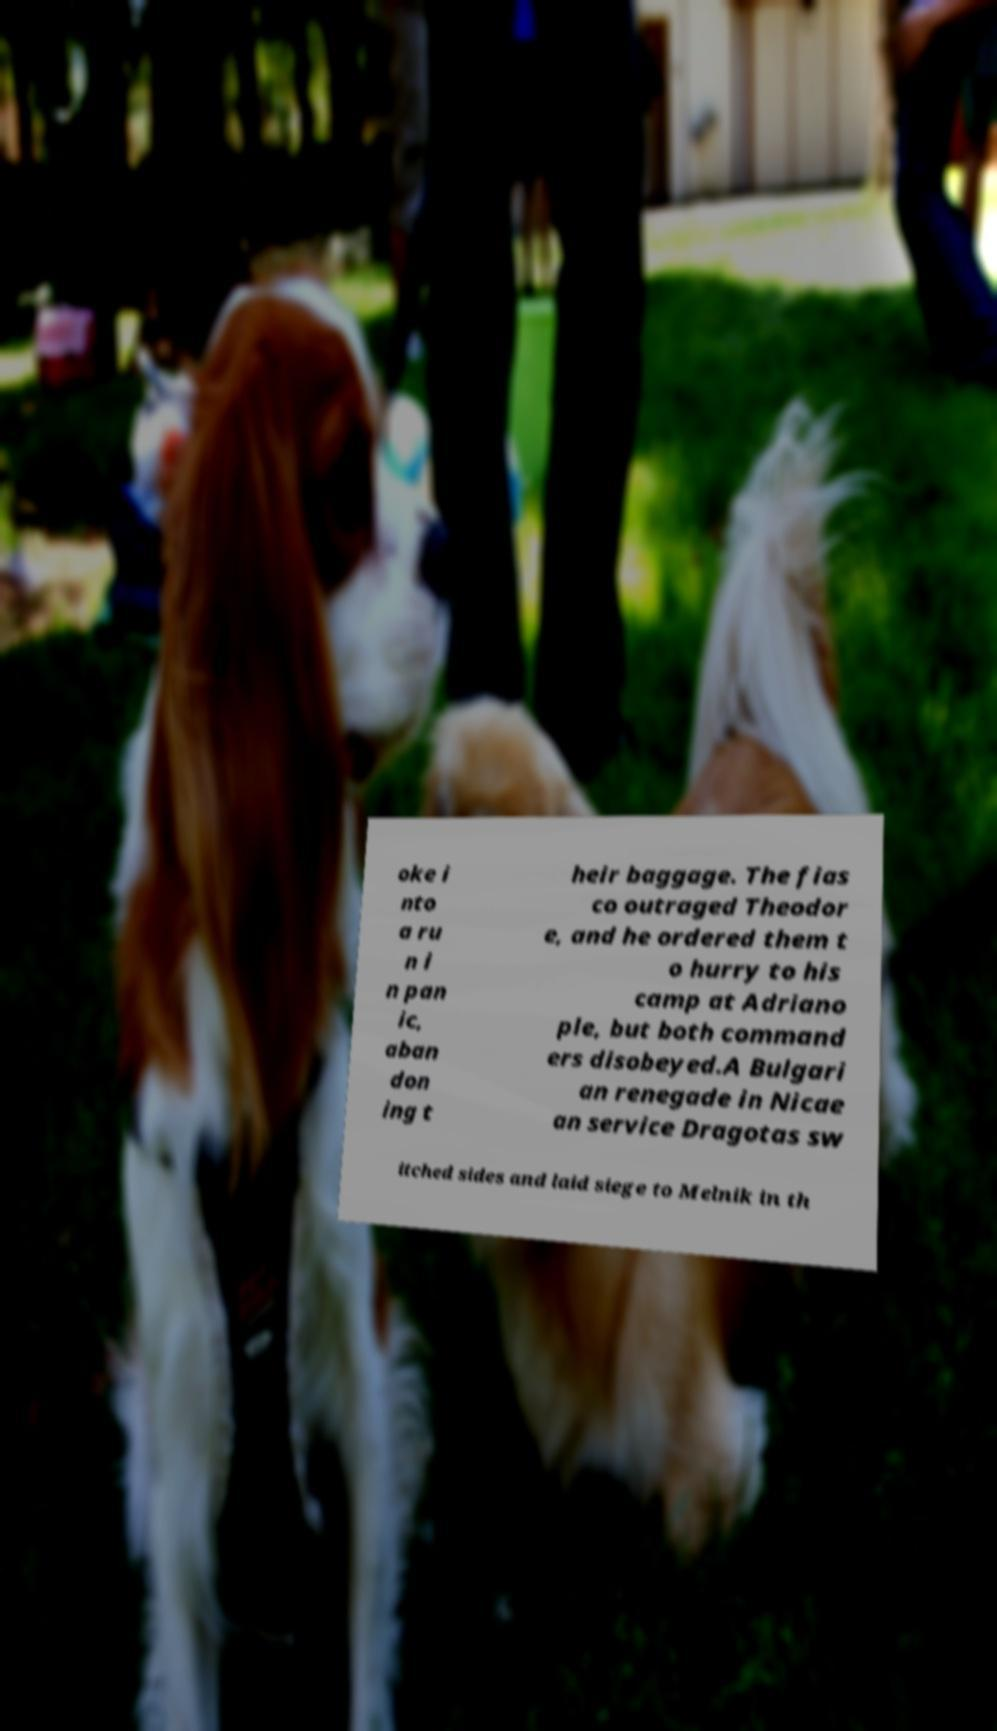Can you accurately transcribe the text from the provided image for me? oke i nto a ru n i n pan ic, aban don ing t heir baggage. The fias co outraged Theodor e, and he ordered them t o hurry to his camp at Adriano ple, but both command ers disobeyed.A Bulgari an renegade in Nicae an service Dragotas sw itched sides and laid siege to Melnik in th 